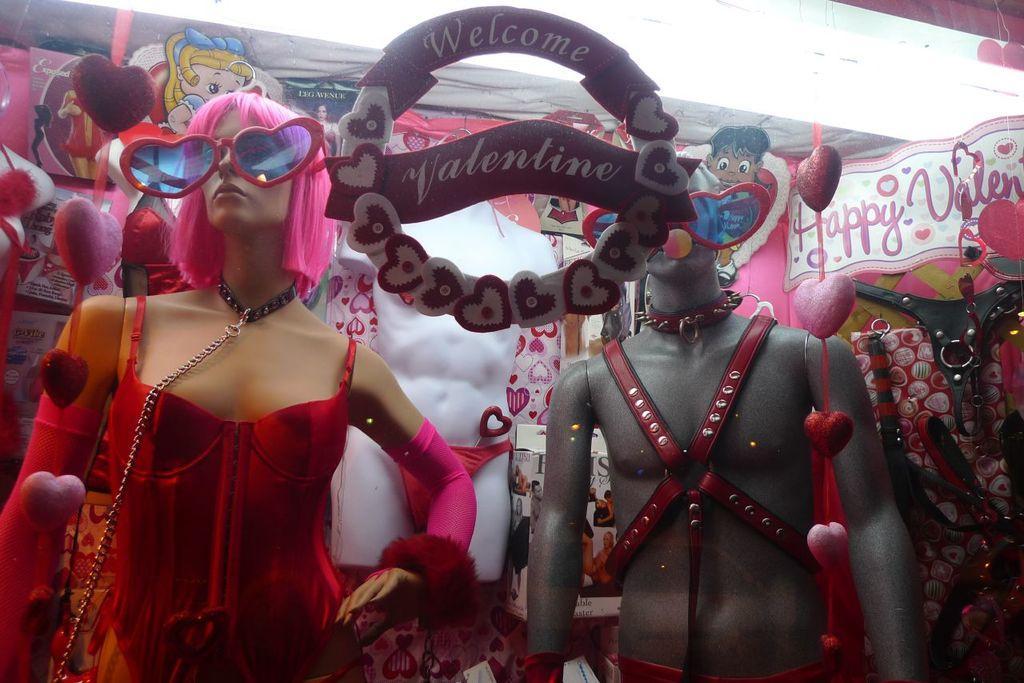Can you describe this image briefly? In this image I can see two people wearing the costumes. In-front of these people I can see the board. In the background I can see many decorative objects and the boards can be seen. 